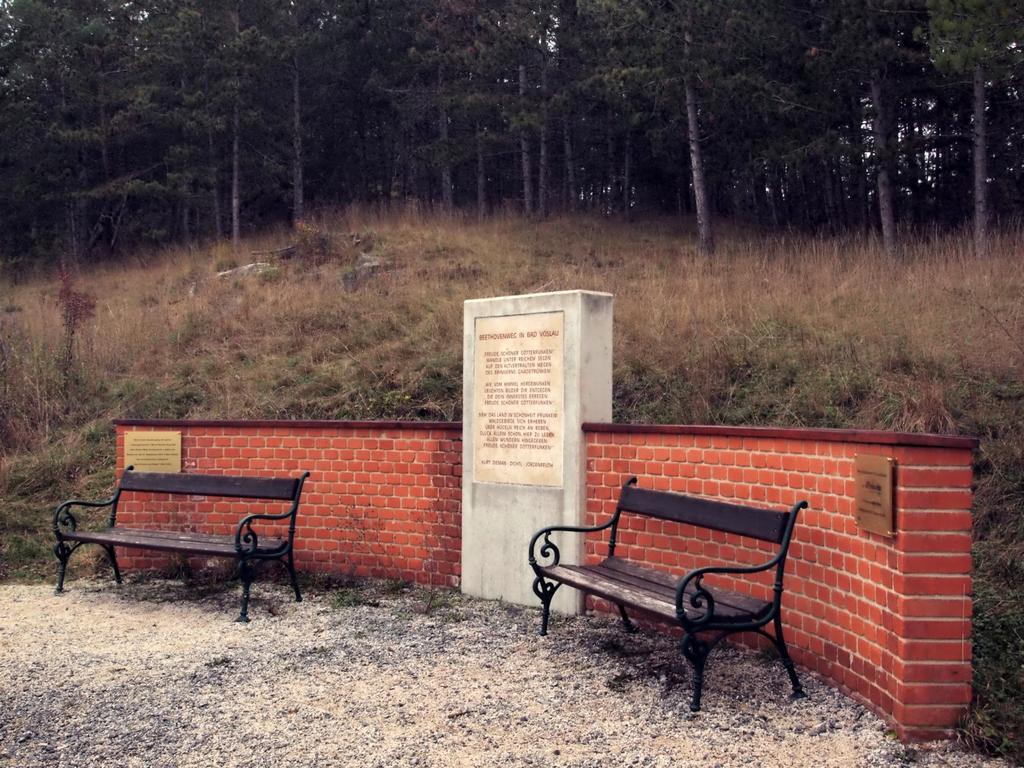In one or two sentences, can you explain what this image depicts? In this image there are benches on the ground. Behind the benches there is a wall. There are boards with text on the wall. Behind the wall there are plants and grass on the hill. In the background there are trees. 